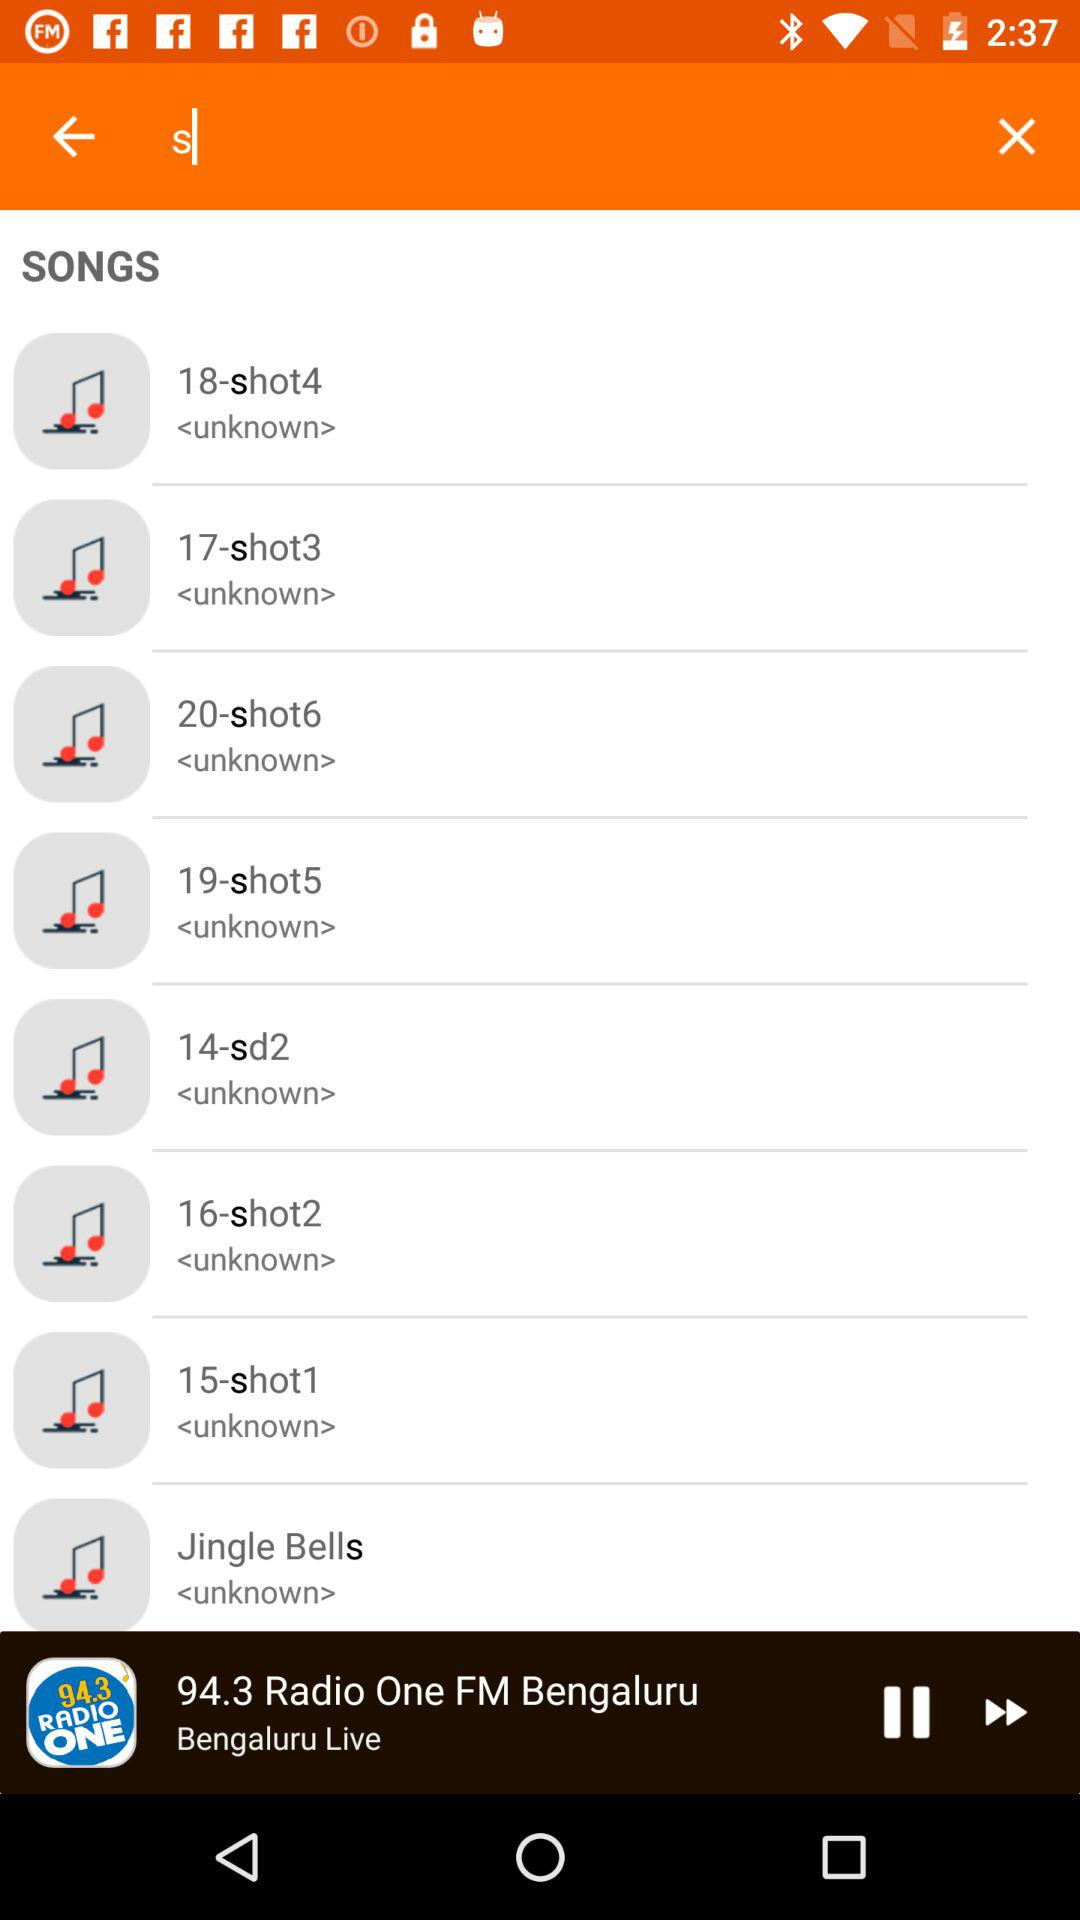Where is the radio live from?
When the provided information is insufficient, respond with <no answer>. <no answer> 